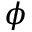<formula> <loc_0><loc_0><loc_500><loc_500>\phi</formula> 